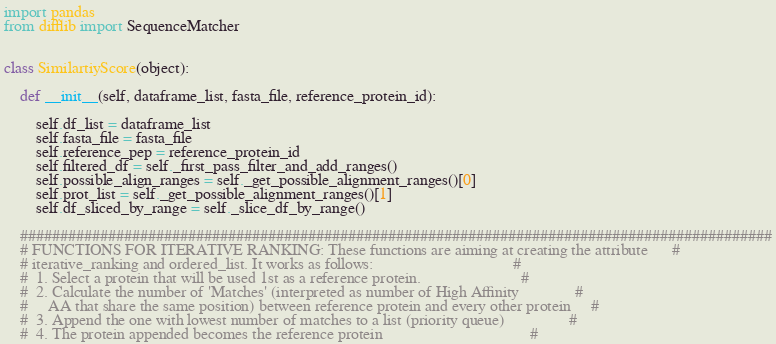Convert code to text. <code><loc_0><loc_0><loc_500><loc_500><_Python_>import pandas
from difflib import SequenceMatcher


class SimilartiyScore(object):

    def __init__(self, dataframe_list, fasta_file, reference_protein_id):

        self.df_list = dataframe_list
        self.fasta_file = fasta_file
        self.reference_pep = reference_protein_id
        self.filtered_df = self._first_pass_filter_and_add_ranges()
        self.possible_align_ranges = self._get_possible_alignment_ranges()[0]
        self.prot_list = self._get_possible_alignment_ranges()[1]
        self.df_sliced_by_range = self._slice_df_by_range()

    ##############################################################################################
    # FUNCTIONS FOR ITERATIVE RANKING: These functions are aiming at creating the attribute      #
    # iterative_ranking and ordered_list. It works as follows:                                   #
    #  1. Select a protein that will be used 1st as a reference protein.                         #
    #  2. Calculate the number of 'Matches' (interpreted as number of High Affinity              #
    #     AA that share the same position) between reference protein and every other protein     #
    #  3. Append the one with lowest number of matches to a list (priority queue)                #
    #  4. The protein appended becomes the reference protein                                     #</code> 